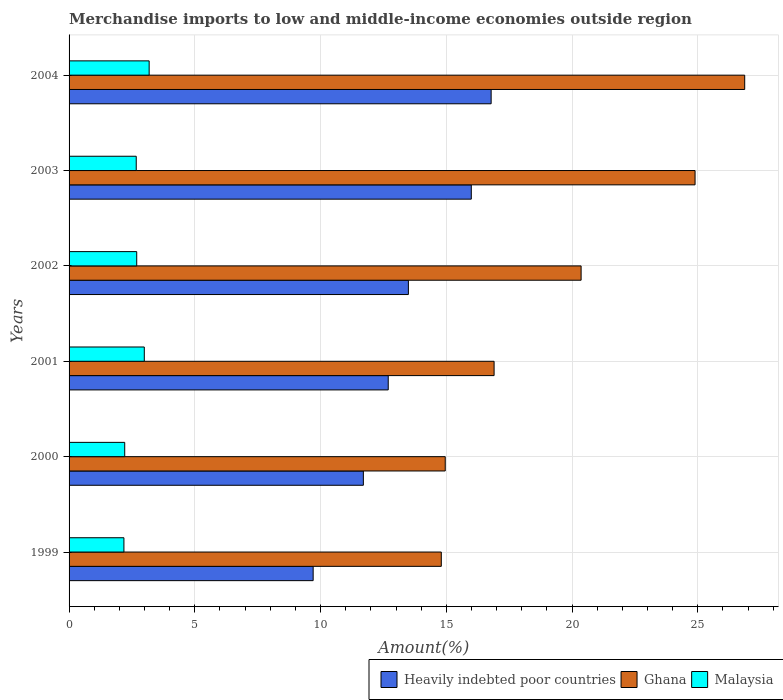How many different coloured bars are there?
Keep it short and to the point. 3. How many groups of bars are there?
Offer a very short reply. 6. What is the label of the 5th group of bars from the top?
Provide a succinct answer. 2000. In how many cases, is the number of bars for a given year not equal to the number of legend labels?
Make the answer very short. 0. What is the percentage of amount earned from merchandise imports in Heavily indebted poor countries in 1999?
Provide a succinct answer. 9.71. Across all years, what is the maximum percentage of amount earned from merchandise imports in Ghana?
Offer a very short reply. 26.87. Across all years, what is the minimum percentage of amount earned from merchandise imports in Heavily indebted poor countries?
Provide a short and direct response. 9.71. What is the total percentage of amount earned from merchandise imports in Ghana in the graph?
Give a very brief answer. 118.78. What is the difference between the percentage of amount earned from merchandise imports in Malaysia in 1999 and that in 2003?
Your answer should be compact. -0.49. What is the difference between the percentage of amount earned from merchandise imports in Malaysia in 2003 and the percentage of amount earned from merchandise imports in Heavily indebted poor countries in 2002?
Provide a short and direct response. -10.82. What is the average percentage of amount earned from merchandise imports in Heavily indebted poor countries per year?
Offer a terse response. 13.39. In the year 2000, what is the difference between the percentage of amount earned from merchandise imports in Ghana and percentage of amount earned from merchandise imports in Malaysia?
Your response must be concise. 12.75. What is the ratio of the percentage of amount earned from merchandise imports in Ghana in 1999 to that in 2000?
Give a very brief answer. 0.99. Is the percentage of amount earned from merchandise imports in Malaysia in 1999 less than that in 2004?
Offer a very short reply. Yes. Is the difference between the percentage of amount earned from merchandise imports in Ghana in 2002 and 2004 greater than the difference between the percentage of amount earned from merchandise imports in Malaysia in 2002 and 2004?
Your answer should be very brief. No. What is the difference between the highest and the second highest percentage of amount earned from merchandise imports in Malaysia?
Make the answer very short. 0.19. What is the difference between the highest and the lowest percentage of amount earned from merchandise imports in Malaysia?
Your response must be concise. 1. In how many years, is the percentage of amount earned from merchandise imports in Heavily indebted poor countries greater than the average percentage of amount earned from merchandise imports in Heavily indebted poor countries taken over all years?
Keep it short and to the point. 3. What does the 2nd bar from the top in 2001 represents?
Give a very brief answer. Ghana. What does the 3rd bar from the bottom in 2003 represents?
Ensure brevity in your answer.  Malaysia. Is it the case that in every year, the sum of the percentage of amount earned from merchandise imports in Heavily indebted poor countries and percentage of amount earned from merchandise imports in Ghana is greater than the percentage of amount earned from merchandise imports in Malaysia?
Offer a very short reply. Yes. Are all the bars in the graph horizontal?
Give a very brief answer. Yes. Does the graph contain grids?
Make the answer very short. Yes. Where does the legend appear in the graph?
Provide a succinct answer. Bottom right. What is the title of the graph?
Your answer should be very brief. Merchandise imports to low and middle-income economies outside region. Does "Andorra" appear as one of the legend labels in the graph?
Make the answer very short. No. What is the label or title of the X-axis?
Offer a very short reply. Amount(%). What is the Amount(%) of Heavily indebted poor countries in 1999?
Offer a terse response. 9.71. What is the Amount(%) of Ghana in 1999?
Your answer should be compact. 14.8. What is the Amount(%) in Malaysia in 1999?
Make the answer very short. 2.18. What is the Amount(%) in Heavily indebted poor countries in 2000?
Provide a succinct answer. 11.7. What is the Amount(%) in Ghana in 2000?
Give a very brief answer. 14.96. What is the Amount(%) in Malaysia in 2000?
Keep it short and to the point. 2.21. What is the Amount(%) of Heavily indebted poor countries in 2001?
Offer a very short reply. 12.69. What is the Amount(%) in Ghana in 2001?
Offer a terse response. 16.9. What is the Amount(%) in Malaysia in 2001?
Your answer should be very brief. 2.99. What is the Amount(%) of Heavily indebted poor countries in 2002?
Ensure brevity in your answer.  13.49. What is the Amount(%) in Ghana in 2002?
Make the answer very short. 20.36. What is the Amount(%) of Malaysia in 2002?
Make the answer very short. 2.69. What is the Amount(%) in Heavily indebted poor countries in 2003?
Provide a succinct answer. 15.99. What is the Amount(%) in Ghana in 2003?
Offer a very short reply. 24.89. What is the Amount(%) in Malaysia in 2003?
Keep it short and to the point. 2.67. What is the Amount(%) in Heavily indebted poor countries in 2004?
Make the answer very short. 16.78. What is the Amount(%) of Ghana in 2004?
Your answer should be very brief. 26.87. What is the Amount(%) of Malaysia in 2004?
Offer a terse response. 3.18. Across all years, what is the maximum Amount(%) of Heavily indebted poor countries?
Provide a succinct answer. 16.78. Across all years, what is the maximum Amount(%) in Ghana?
Provide a succinct answer. 26.87. Across all years, what is the maximum Amount(%) of Malaysia?
Your answer should be compact. 3.18. Across all years, what is the minimum Amount(%) of Heavily indebted poor countries?
Your answer should be compact. 9.71. Across all years, what is the minimum Amount(%) of Ghana?
Provide a succinct answer. 14.8. Across all years, what is the minimum Amount(%) in Malaysia?
Offer a very short reply. 2.18. What is the total Amount(%) in Heavily indebted poor countries in the graph?
Keep it short and to the point. 80.37. What is the total Amount(%) in Ghana in the graph?
Your response must be concise. 118.78. What is the total Amount(%) in Malaysia in the graph?
Provide a short and direct response. 15.93. What is the difference between the Amount(%) of Heavily indebted poor countries in 1999 and that in 2000?
Provide a succinct answer. -2. What is the difference between the Amount(%) in Ghana in 1999 and that in 2000?
Provide a succinct answer. -0.16. What is the difference between the Amount(%) of Malaysia in 1999 and that in 2000?
Your response must be concise. -0.03. What is the difference between the Amount(%) in Heavily indebted poor countries in 1999 and that in 2001?
Your response must be concise. -2.99. What is the difference between the Amount(%) of Ghana in 1999 and that in 2001?
Offer a very short reply. -2.1. What is the difference between the Amount(%) in Malaysia in 1999 and that in 2001?
Offer a terse response. -0.81. What is the difference between the Amount(%) in Heavily indebted poor countries in 1999 and that in 2002?
Ensure brevity in your answer.  -3.79. What is the difference between the Amount(%) in Ghana in 1999 and that in 2002?
Your response must be concise. -5.56. What is the difference between the Amount(%) in Malaysia in 1999 and that in 2002?
Make the answer very short. -0.51. What is the difference between the Amount(%) of Heavily indebted poor countries in 1999 and that in 2003?
Provide a succinct answer. -6.29. What is the difference between the Amount(%) in Ghana in 1999 and that in 2003?
Make the answer very short. -10.09. What is the difference between the Amount(%) of Malaysia in 1999 and that in 2003?
Offer a very short reply. -0.49. What is the difference between the Amount(%) in Heavily indebted poor countries in 1999 and that in 2004?
Keep it short and to the point. -7.08. What is the difference between the Amount(%) of Ghana in 1999 and that in 2004?
Make the answer very short. -12.06. What is the difference between the Amount(%) of Malaysia in 1999 and that in 2004?
Ensure brevity in your answer.  -1. What is the difference between the Amount(%) of Heavily indebted poor countries in 2000 and that in 2001?
Your response must be concise. -0.99. What is the difference between the Amount(%) in Ghana in 2000 and that in 2001?
Your answer should be very brief. -1.94. What is the difference between the Amount(%) in Malaysia in 2000 and that in 2001?
Make the answer very short. -0.78. What is the difference between the Amount(%) of Heavily indebted poor countries in 2000 and that in 2002?
Make the answer very short. -1.79. What is the difference between the Amount(%) of Ghana in 2000 and that in 2002?
Offer a very short reply. -5.4. What is the difference between the Amount(%) in Malaysia in 2000 and that in 2002?
Give a very brief answer. -0.48. What is the difference between the Amount(%) in Heavily indebted poor countries in 2000 and that in 2003?
Make the answer very short. -4.29. What is the difference between the Amount(%) of Ghana in 2000 and that in 2003?
Your response must be concise. -9.93. What is the difference between the Amount(%) in Malaysia in 2000 and that in 2003?
Provide a succinct answer. -0.46. What is the difference between the Amount(%) in Heavily indebted poor countries in 2000 and that in 2004?
Your answer should be compact. -5.08. What is the difference between the Amount(%) in Ghana in 2000 and that in 2004?
Give a very brief answer. -11.91. What is the difference between the Amount(%) in Malaysia in 2000 and that in 2004?
Ensure brevity in your answer.  -0.97. What is the difference between the Amount(%) in Heavily indebted poor countries in 2001 and that in 2002?
Your response must be concise. -0.8. What is the difference between the Amount(%) in Ghana in 2001 and that in 2002?
Provide a short and direct response. -3.46. What is the difference between the Amount(%) of Malaysia in 2001 and that in 2002?
Provide a succinct answer. 0.3. What is the difference between the Amount(%) of Heavily indebted poor countries in 2001 and that in 2003?
Your answer should be compact. -3.3. What is the difference between the Amount(%) of Ghana in 2001 and that in 2003?
Offer a very short reply. -7.99. What is the difference between the Amount(%) of Malaysia in 2001 and that in 2003?
Your answer should be very brief. 0.32. What is the difference between the Amount(%) in Heavily indebted poor countries in 2001 and that in 2004?
Provide a short and direct response. -4.09. What is the difference between the Amount(%) in Ghana in 2001 and that in 2004?
Keep it short and to the point. -9.97. What is the difference between the Amount(%) of Malaysia in 2001 and that in 2004?
Ensure brevity in your answer.  -0.19. What is the difference between the Amount(%) in Heavily indebted poor countries in 2002 and that in 2003?
Offer a very short reply. -2.5. What is the difference between the Amount(%) in Ghana in 2002 and that in 2003?
Give a very brief answer. -4.53. What is the difference between the Amount(%) of Malaysia in 2002 and that in 2003?
Your answer should be very brief. 0.02. What is the difference between the Amount(%) in Heavily indebted poor countries in 2002 and that in 2004?
Provide a succinct answer. -3.29. What is the difference between the Amount(%) of Ghana in 2002 and that in 2004?
Keep it short and to the point. -6.51. What is the difference between the Amount(%) of Malaysia in 2002 and that in 2004?
Provide a succinct answer. -0.49. What is the difference between the Amount(%) of Heavily indebted poor countries in 2003 and that in 2004?
Keep it short and to the point. -0.79. What is the difference between the Amount(%) of Ghana in 2003 and that in 2004?
Your response must be concise. -1.97. What is the difference between the Amount(%) in Malaysia in 2003 and that in 2004?
Provide a succinct answer. -0.51. What is the difference between the Amount(%) of Heavily indebted poor countries in 1999 and the Amount(%) of Ghana in 2000?
Give a very brief answer. -5.25. What is the difference between the Amount(%) of Heavily indebted poor countries in 1999 and the Amount(%) of Malaysia in 2000?
Provide a succinct answer. 7.49. What is the difference between the Amount(%) in Ghana in 1999 and the Amount(%) in Malaysia in 2000?
Offer a terse response. 12.59. What is the difference between the Amount(%) of Heavily indebted poor countries in 1999 and the Amount(%) of Ghana in 2001?
Provide a short and direct response. -7.19. What is the difference between the Amount(%) of Heavily indebted poor countries in 1999 and the Amount(%) of Malaysia in 2001?
Your answer should be very brief. 6.71. What is the difference between the Amount(%) of Ghana in 1999 and the Amount(%) of Malaysia in 2001?
Offer a very short reply. 11.81. What is the difference between the Amount(%) in Heavily indebted poor countries in 1999 and the Amount(%) in Ghana in 2002?
Your answer should be compact. -10.66. What is the difference between the Amount(%) of Heavily indebted poor countries in 1999 and the Amount(%) of Malaysia in 2002?
Provide a succinct answer. 7.02. What is the difference between the Amount(%) of Ghana in 1999 and the Amount(%) of Malaysia in 2002?
Provide a short and direct response. 12.11. What is the difference between the Amount(%) in Heavily indebted poor countries in 1999 and the Amount(%) in Ghana in 2003?
Offer a terse response. -15.19. What is the difference between the Amount(%) of Heavily indebted poor countries in 1999 and the Amount(%) of Malaysia in 2003?
Offer a very short reply. 7.03. What is the difference between the Amount(%) of Ghana in 1999 and the Amount(%) of Malaysia in 2003?
Offer a terse response. 12.13. What is the difference between the Amount(%) in Heavily indebted poor countries in 1999 and the Amount(%) in Ghana in 2004?
Provide a succinct answer. -17.16. What is the difference between the Amount(%) of Heavily indebted poor countries in 1999 and the Amount(%) of Malaysia in 2004?
Offer a terse response. 6.52. What is the difference between the Amount(%) in Ghana in 1999 and the Amount(%) in Malaysia in 2004?
Give a very brief answer. 11.62. What is the difference between the Amount(%) in Heavily indebted poor countries in 2000 and the Amount(%) in Ghana in 2001?
Keep it short and to the point. -5.2. What is the difference between the Amount(%) in Heavily indebted poor countries in 2000 and the Amount(%) in Malaysia in 2001?
Offer a terse response. 8.71. What is the difference between the Amount(%) in Ghana in 2000 and the Amount(%) in Malaysia in 2001?
Make the answer very short. 11.97. What is the difference between the Amount(%) in Heavily indebted poor countries in 2000 and the Amount(%) in Ghana in 2002?
Your response must be concise. -8.66. What is the difference between the Amount(%) of Heavily indebted poor countries in 2000 and the Amount(%) of Malaysia in 2002?
Your answer should be very brief. 9.01. What is the difference between the Amount(%) of Ghana in 2000 and the Amount(%) of Malaysia in 2002?
Offer a terse response. 12.27. What is the difference between the Amount(%) in Heavily indebted poor countries in 2000 and the Amount(%) in Ghana in 2003?
Ensure brevity in your answer.  -13.19. What is the difference between the Amount(%) in Heavily indebted poor countries in 2000 and the Amount(%) in Malaysia in 2003?
Ensure brevity in your answer.  9.03. What is the difference between the Amount(%) of Ghana in 2000 and the Amount(%) of Malaysia in 2003?
Provide a short and direct response. 12.29. What is the difference between the Amount(%) of Heavily indebted poor countries in 2000 and the Amount(%) of Ghana in 2004?
Keep it short and to the point. -15.16. What is the difference between the Amount(%) in Heavily indebted poor countries in 2000 and the Amount(%) in Malaysia in 2004?
Give a very brief answer. 8.52. What is the difference between the Amount(%) in Ghana in 2000 and the Amount(%) in Malaysia in 2004?
Provide a succinct answer. 11.77. What is the difference between the Amount(%) in Heavily indebted poor countries in 2001 and the Amount(%) in Ghana in 2002?
Offer a very short reply. -7.67. What is the difference between the Amount(%) of Heavily indebted poor countries in 2001 and the Amount(%) of Malaysia in 2002?
Your answer should be very brief. 10. What is the difference between the Amount(%) in Ghana in 2001 and the Amount(%) in Malaysia in 2002?
Your answer should be very brief. 14.21. What is the difference between the Amount(%) in Heavily indebted poor countries in 2001 and the Amount(%) in Ghana in 2003?
Your response must be concise. -12.2. What is the difference between the Amount(%) in Heavily indebted poor countries in 2001 and the Amount(%) in Malaysia in 2003?
Provide a short and direct response. 10.02. What is the difference between the Amount(%) in Ghana in 2001 and the Amount(%) in Malaysia in 2003?
Keep it short and to the point. 14.23. What is the difference between the Amount(%) in Heavily indebted poor countries in 2001 and the Amount(%) in Ghana in 2004?
Your response must be concise. -14.17. What is the difference between the Amount(%) of Heavily indebted poor countries in 2001 and the Amount(%) of Malaysia in 2004?
Offer a very short reply. 9.51. What is the difference between the Amount(%) of Ghana in 2001 and the Amount(%) of Malaysia in 2004?
Your answer should be compact. 13.72. What is the difference between the Amount(%) of Heavily indebted poor countries in 2002 and the Amount(%) of Ghana in 2003?
Give a very brief answer. -11.4. What is the difference between the Amount(%) in Heavily indebted poor countries in 2002 and the Amount(%) in Malaysia in 2003?
Your response must be concise. 10.82. What is the difference between the Amount(%) of Ghana in 2002 and the Amount(%) of Malaysia in 2003?
Your response must be concise. 17.69. What is the difference between the Amount(%) of Heavily indebted poor countries in 2002 and the Amount(%) of Ghana in 2004?
Offer a terse response. -13.37. What is the difference between the Amount(%) in Heavily indebted poor countries in 2002 and the Amount(%) in Malaysia in 2004?
Your response must be concise. 10.31. What is the difference between the Amount(%) in Ghana in 2002 and the Amount(%) in Malaysia in 2004?
Make the answer very short. 17.18. What is the difference between the Amount(%) in Heavily indebted poor countries in 2003 and the Amount(%) in Ghana in 2004?
Provide a short and direct response. -10.87. What is the difference between the Amount(%) of Heavily indebted poor countries in 2003 and the Amount(%) of Malaysia in 2004?
Your answer should be very brief. 12.81. What is the difference between the Amount(%) in Ghana in 2003 and the Amount(%) in Malaysia in 2004?
Give a very brief answer. 21.71. What is the average Amount(%) of Heavily indebted poor countries per year?
Provide a succinct answer. 13.39. What is the average Amount(%) in Ghana per year?
Give a very brief answer. 19.8. What is the average Amount(%) in Malaysia per year?
Offer a terse response. 2.65. In the year 1999, what is the difference between the Amount(%) in Heavily indebted poor countries and Amount(%) in Ghana?
Provide a succinct answer. -5.1. In the year 1999, what is the difference between the Amount(%) of Heavily indebted poor countries and Amount(%) of Malaysia?
Offer a very short reply. 7.52. In the year 1999, what is the difference between the Amount(%) of Ghana and Amount(%) of Malaysia?
Offer a very short reply. 12.62. In the year 2000, what is the difference between the Amount(%) in Heavily indebted poor countries and Amount(%) in Ghana?
Offer a very short reply. -3.26. In the year 2000, what is the difference between the Amount(%) of Heavily indebted poor countries and Amount(%) of Malaysia?
Keep it short and to the point. 9.49. In the year 2000, what is the difference between the Amount(%) in Ghana and Amount(%) in Malaysia?
Make the answer very short. 12.75. In the year 2001, what is the difference between the Amount(%) in Heavily indebted poor countries and Amount(%) in Ghana?
Provide a succinct answer. -4.21. In the year 2001, what is the difference between the Amount(%) of Heavily indebted poor countries and Amount(%) of Malaysia?
Give a very brief answer. 9.7. In the year 2001, what is the difference between the Amount(%) of Ghana and Amount(%) of Malaysia?
Offer a terse response. 13.91. In the year 2002, what is the difference between the Amount(%) in Heavily indebted poor countries and Amount(%) in Ghana?
Ensure brevity in your answer.  -6.87. In the year 2002, what is the difference between the Amount(%) of Heavily indebted poor countries and Amount(%) of Malaysia?
Your response must be concise. 10.8. In the year 2002, what is the difference between the Amount(%) of Ghana and Amount(%) of Malaysia?
Ensure brevity in your answer.  17.67. In the year 2003, what is the difference between the Amount(%) of Heavily indebted poor countries and Amount(%) of Ghana?
Your response must be concise. -8.9. In the year 2003, what is the difference between the Amount(%) in Heavily indebted poor countries and Amount(%) in Malaysia?
Your response must be concise. 13.32. In the year 2003, what is the difference between the Amount(%) in Ghana and Amount(%) in Malaysia?
Ensure brevity in your answer.  22.22. In the year 2004, what is the difference between the Amount(%) in Heavily indebted poor countries and Amount(%) in Ghana?
Provide a succinct answer. -10.08. In the year 2004, what is the difference between the Amount(%) in Heavily indebted poor countries and Amount(%) in Malaysia?
Provide a short and direct response. 13.6. In the year 2004, what is the difference between the Amount(%) in Ghana and Amount(%) in Malaysia?
Provide a succinct answer. 23.68. What is the ratio of the Amount(%) of Heavily indebted poor countries in 1999 to that in 2000?
Ensure brevity in your answer.  0.83. What is the ratio of the Amount(%) of Ghana in 1999 to that in 2000?
Provide a succinct answer. 0.99. What is the ratio of the Amount(%) in Malaysia in 1999 to that in 2000?
Ensure brevity in your answer.  0.99. What is the ratio of the Amount(%) of Heavily indebted poor countries in 1999 to that in 2001?
Offer a very short reply. 0.76. What is the ratio of the Amount(%) in Ghana in 1999 to that in 2001?
Offer a very short reply. 0.88. What is the ratio of the Amount(%) of Malaysia in 1999 to that in 2001?
Offer a very short reply. 0.73. What is the ratio of the Amount(%) of Heavily indebted poor countries in 1999 to that in 2002?
Keep it short and to the point. 0.72. What is the ratio of the Amount(%) of Ghana in 1999 to that in 2002?
Offer a very short reply. 0.73. What is the ratio of the Amount(%) in Malaysia in 1999 to that in 2002?
Provide a short and direct response. 0.81. What is the ratio of the Amount(%) of Heavily indebted poor countries in 1999 to that in 2003?
Give a very brief answer. 0.61. What is the ratio of the Amount(%) of Ghana in 1999 to that in 2003?
Keep it short and to the point. 0.59. What is the ratio of the Amount(%) in Malaysia in 1999 to that in 2003?
Offer a very short reply. 0.82. What is the ratio of the Amount(%) in Heavily indebted poor countries in 1999 to that in 2004?
Make the answer very short. 0.58. What is the ratio of the Amount(%) of Ghana in 1999 to that in 2004?
Your answer should be compact. 0.55. What is the ratio of the Amount(%) in Malaysia in 1999 to that in 2004?
Offer a terse response. 0.68. What is the ratio of the Amount(%) of Heavily indebted poor countries in 2000 to that in 2001?
Offer a very short reply. 0.92. What is the ratio of the Amount(%) of Ghana in 2000 to that in 2001?
Offer a very short reply. 0.89. What is the ratio of the Amount(%) in Malaysia in 2000 to that in 2001?
Your answer should be very brief. 0.74. What is the ratio of the Amount(%) in Heavily indebted poor countries in 2000 to that in 2002?
Provide a succinct answer. 0.87. What is the ratio of the Amount(%) of Ghana in 2000 to that in 2002?
Your response must be concise. 0.73. What is the ratio of the Amount(%) in Malaysia in 2000 to that in 2002?
Your answer should be compact. 0.82. What is the ratio of the Amount(%) of Heavily indebted poor countries in 2000 to that in 2003?
Provide a short and direct response. 0.73. What is the ratio of the Amount(%) in Ghana in 2000 to that in 2003?
Your response must be concise. 0.6. What is the ratio of the Amount(%) of Malaysia in 2000 to that in 2003?
Give a very brief answer. 0.83. What is the ratio of the Amount(%) in Heavily indebted poor countries in 2000 to that in 2004?
Provide a succinct answer. 0.7. What is the ratio of the Amount(%) in Ghana in 2000 to that in 2004?
Make the answer very short. 0.56. What is the ratio of the Amount(%) in Malaysia in 2000 to that in 2004?
Keep it short and to the point. 0.69. What is the ratio of the Amount(%) of Heavily indebted poor countries in 2001 to that in 2002?
Give a very brief answer. 0.94. What is the ratio of the Amount(%) of Ghana in 2001 to that in 2002?
Make the answer very short. 0.83. What is the ratio of the Amount(%) of Malaysia in 2001 to that in 2002?
Your answer should be compact. 1.11. What is the ratio of the Amount(%) of Heavily indebted poor countries in 2001 to that in 2003?
Provide a short and direct response. 0.79. What is the ratio of the Amount(%) of Ghana in 2001 to that in 2003?
Ensure brevity in your answer.  0.68. What is the ratio of the Amount(%) of Malaysia in 2001 to that in 2003?
Your answer should be very brief. 1.12. What is the ratio of the Amount(%) of Heavily indebted poor countries in 2001 to that in 2004?
Offer a very short reply. 0.76. What is the ratio of the Amount(%) of Ghana in 2001 to that in 2004?
Offer a very short reply. 0.63. What is the ratio of the Amount(%) of Malaysia in 2001 to that in 2004?
Offer a terse response. 0.94. What is the ratio of the Amount(%) of Heavily indebted poor countries in 2002 to that in 2003?
Offer a terse response. 0.84. What is the ratio of the Amount(%) of Ghana in 2002 to that in 2003?
Your response must be concise. 0.82. What is the ratio of the Amount(%) of Malaysia in 2002 to that in 2003?
Offer a terse response. 1.01. What is the ratio of the Amount(%) in Heavily indebted poor countries in 2002 to that in 2004?
Your answer should be compact. 0.8. What is the ratio of the Amount(%) of Ghana in 2002 to that in 2004?
Provide a short and direct response. 0.76. What is the ratio of the Amount(%) of Malaysia in 2002 to that in 2004?
Offer a very short reply. 0.84. What is the ratio of the Amount(%) in Heavily indebted poor countries in 2003 to that in 2004?
Your answer should be very brief. 0.95. What is the ratio of the Amount(%) of Ghana in 2003 to that in 2004?
Your answer should be very brief. 0.93. What is the ratio of the Amount(%) in Malaysia in 2003 to that in 2004?
Keep it short and to the point. 0.84. What is the difference between the highest and the second highest Amount(%) of Heavily indebted poor countries?
Give a very brief answer. 0.79. What is the difference between the highest and the second highest Amount(%) in Ghana?
Make the answer very short. 1.97. What is the difference between the highest and the second highest Amount(%) of Malaysia?
Provide a succinct answer. 0.19. What is the difference between the highest and the lowest Amount(%) of Heavily indebted poor countries?
Provide a short and direct response. 7.08. What is the difference between the highest and the lowest Amount(%) of Ghana?
Offer a terse response. 12.06. 